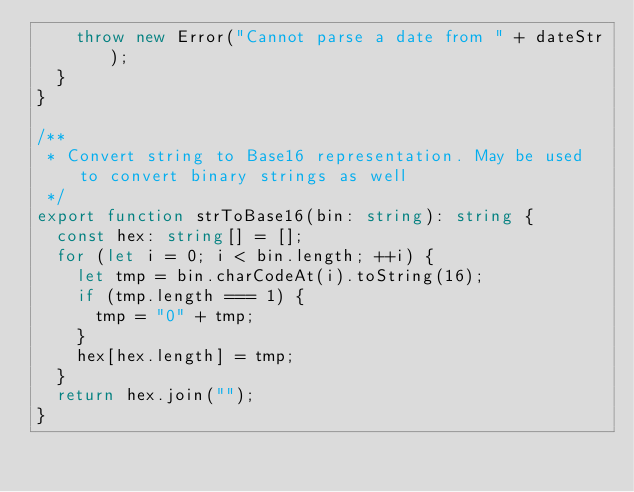<code> <loc_0><loc_0><loc_500><loc_500><_TypeScript_>    throw new Error("Cannot parse a date from " + dateStr);
  }
}

/**
 * Convert string to Base16 representation. May be used to convert binary strings as well
 */
export function strToBase16(bin: string): string {
  const hex: string[] = [];
  for (let i = 0; i < bin.length; ++i) {
    let tmp = bin.charCodeAt(i).toString(16);
    if (tmp.length === 1) {
      tmp = "0" + tmp;
    }
    hex[hex.length] = tmp;
  }
  return hex.join("");
}
</code> 